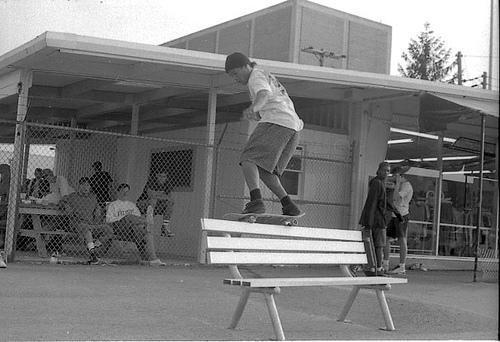How many people are in the picture?
Give a very brief answer. 3. How many total elephants are visible?
Give a very brief answer. 0. 